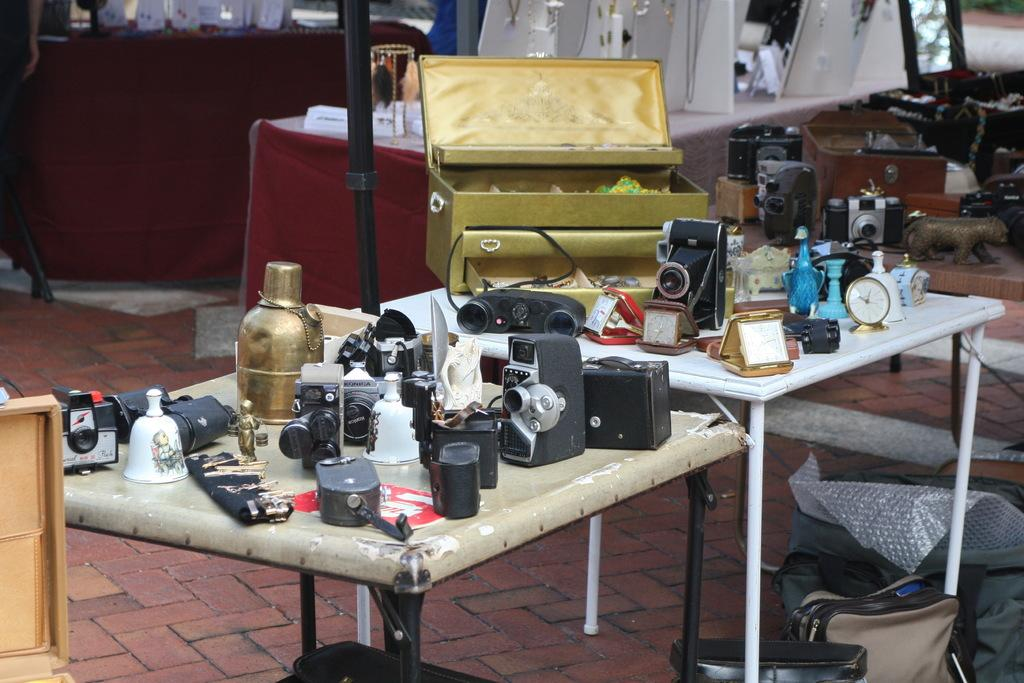What piece of furniture is present in the image? There is a table in the image. What is placed on the table? There is a camera on the table, and there are other objects present as well. Can you describe the location of the bag in the image? The bag is on the floor in the image. What color is the paint on the dock in the image? There is no dock or paint present in the image. How many balloons are tied to the camera on the table? There are no balloons present in the image; only the camera and other objects are visible on the table. 